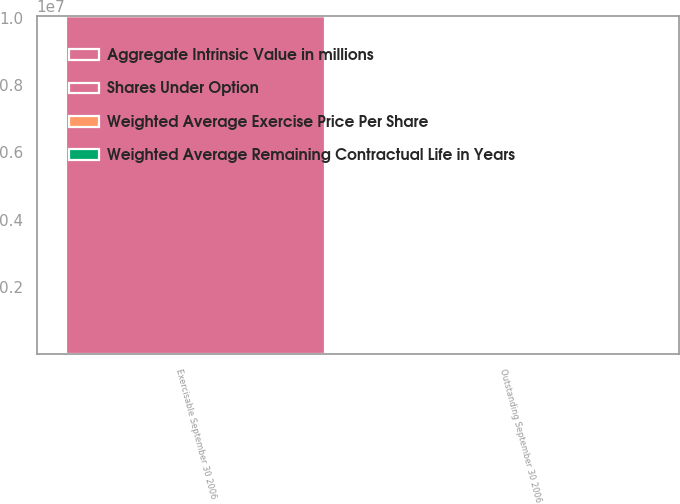Convert chart to OTSL. <chart><loc_0><loc_0><loc_500><loc_500><stacked_bar_chart><ecel><fcel>Outstanding September 30 2006<fcel>Exercisable September 30 2006<nl><fcel>Aggregate Intrinsic Value in millions<fcel>13.79<fcel>1.00549e+07<nl><fcel>Weighted Average Exercise Price Per Share<fcel>13.79<fcel>13.1<nl><fcel>Shares Under Option<fcel>6<fcel>4.5<nl><fcel>Weighted Average Remaining Contractual Life in Years<fcel>43<fcel>32<nl></chart> 